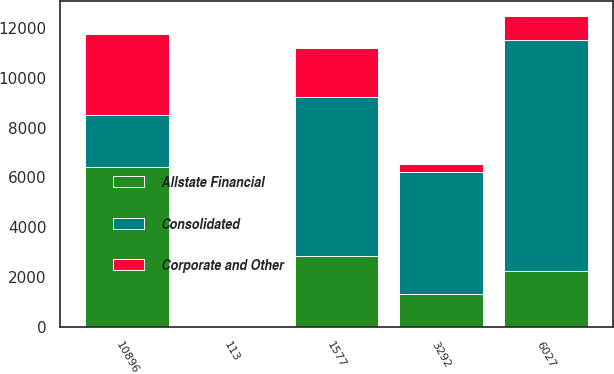<chart> <loc_0><loc_0><loc_500><loc_500><stacked_bar_chart><ecel><fcel>1577<fcel>3292<fcel>6027<fcel>10896<fcel>113<nl><fcel>Allstate Financial<fcel>2825<fcel>1320<fcel>2258<fcel>6403<fcel>6.6<nl><fcel>Corporate and Other<fcel>1993<fcel>295<fcel>972<fcel>3260<fcel>3.4<nl><fcel>Consolidated<fcel>6395<fcel>4907<fcel>9257<fcel>2125.5<fcel>21.3<nl></chart> 